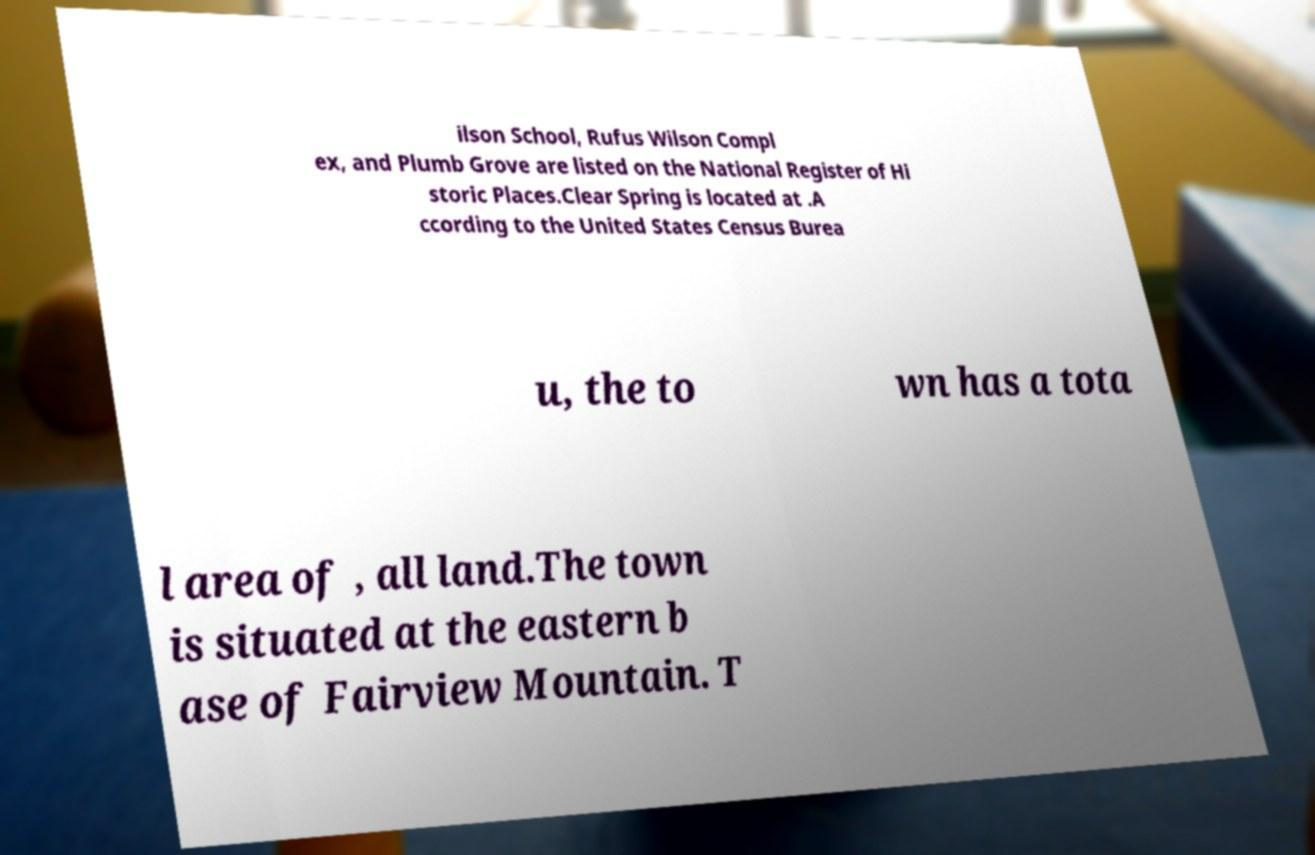Please identify and transcribe the text found in this image. ilson School, Rufus Wilson Compl ex, and Plumb Grove are listed on the National Register of Hi storic Places.Clear Spring is located at .A ccording to the United States Census Burea u, the to wn has a tota l area of , all land.The town is situated at the eastern b ase of Fairview Mountain. T 